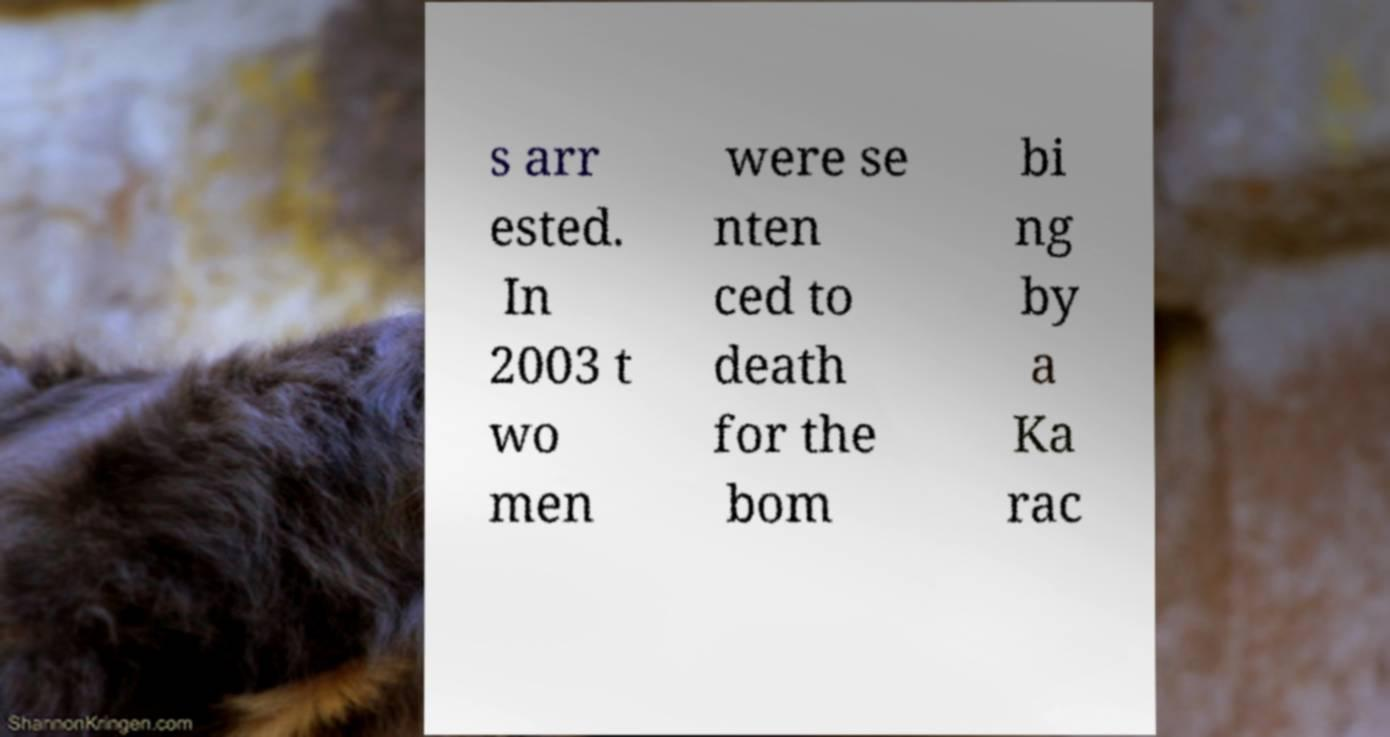Could you extract and type out the text from this image? s arr ested. In 2003 t wo men were se nten ced to death for the bom bi ng by a Ka rac 